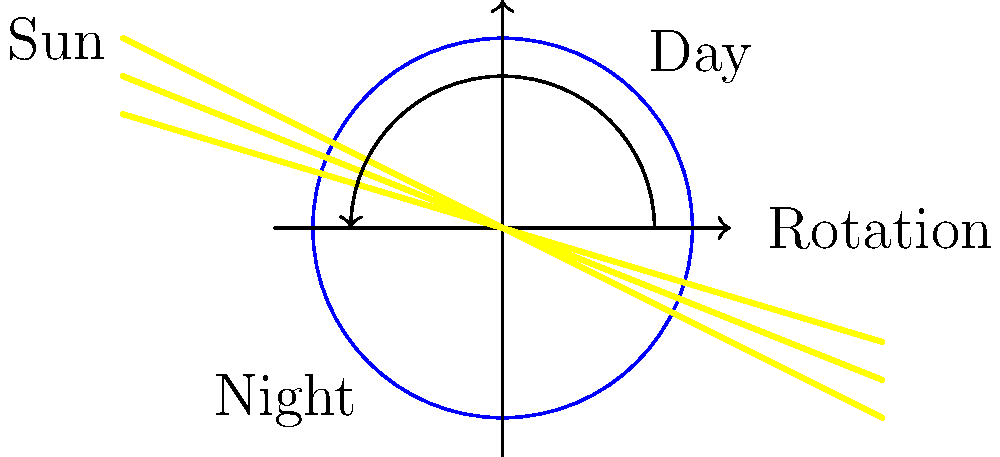Using the illustration of a globe and light source, explain how the Earth's rotation causes day and night. How would you demonstrate this concept to your students using simple classroom materials? 1. Earth's shape: The Earth is roughly spherical, as shown by the circle in the diagram.

2. Light source: The Sun, represented by the yellow rays coming from the left, illuminates one half of the Earth at a time.

3. Rotation: The Earth rotates on its axis, as indicated by the curved arrow in the diagram. This rotation takes approximately 24 hours, which we call a day.

4. Day and night: The side of the Earth facing the Sun experiences daylight, while the opposite side is in darkness (night).

5. Continuous cycle: As the Earth rotates, different parts of its surface face the Sun, creating a continuous cycle of day and night.

To demonstrate this to students:

1. Use a globe to represent the Earth.
2. Shine a bright flashlight or lamp (the "Sun") on one side of the globe.
3. Slowly rotate the globe to show how different areas move into and out of the light.
4. Mark a spot on the globe with a sticker to represent Beccles, and observe how it moves between light and dark as the globe rotates.

This hands-on demonstration helps students visualize the concept and relate it to their daily experiences of sunrise and sunset.
Answer: Earth's rotation causes day and night by exposing different parts of its surface to sunlight as it spins on its axis every 24 hours. 